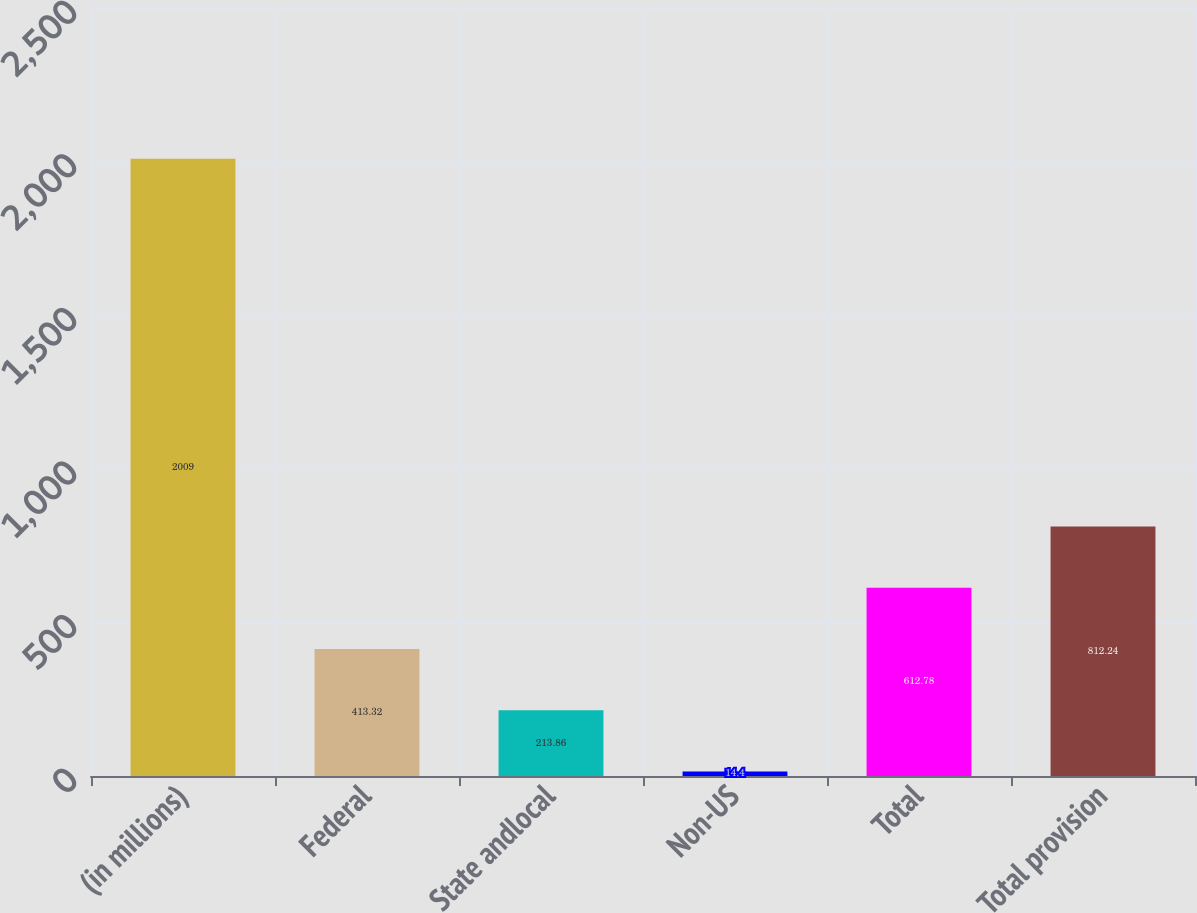<chart> <loc_0><loc_0><loc_500><loc_500><bar_chart><fcel>(in millions)<fcel>Federal<fcel>State andlocal<fcel>Non-US<fcel>Total<fcel>Total provision<nl><fcel>2009<fcel>413.32<fcel>213.86<fcel>14.4<fcel>612.78<fcel>812.24<nl></chart> 